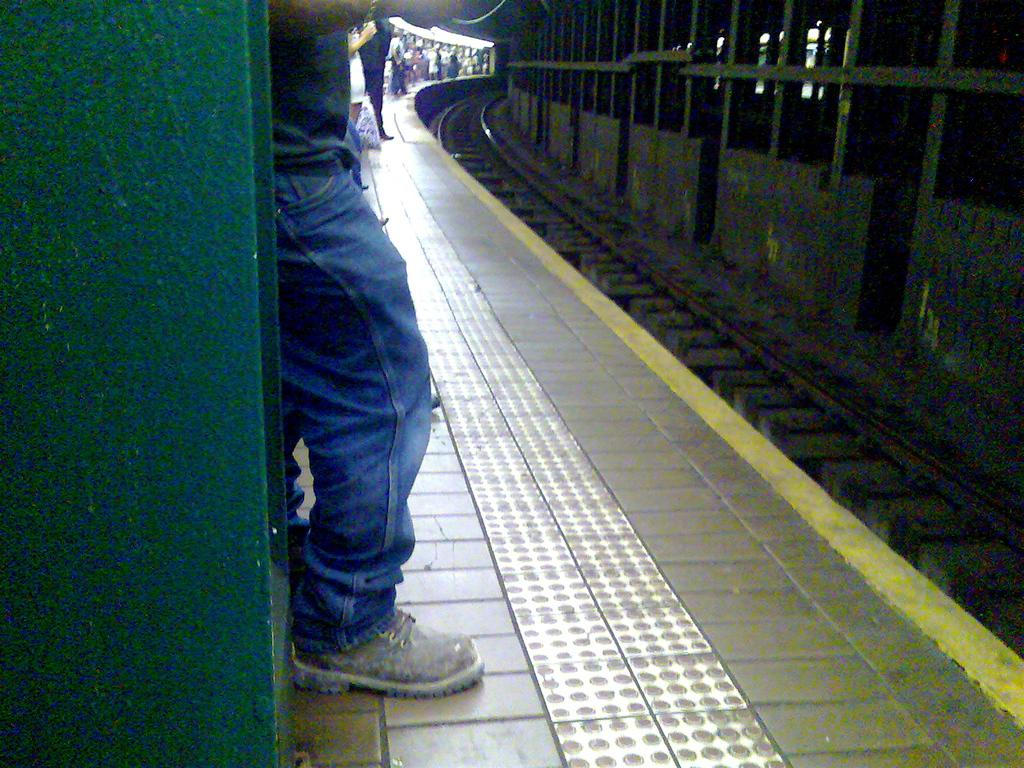What can be seen in the image that resembles a path or route? There is a track in the image. Where are the people located in relation to the track? The people are standing on a platform to the left of the track. What can be observed about the people's clothing? The people are wearing different color dresses. What direction is the track facing in the image? The direction the track is facing cannot be determined from the image. Are any of the people wearing masks in the image? There are no masks visible on any of the people in the image. 